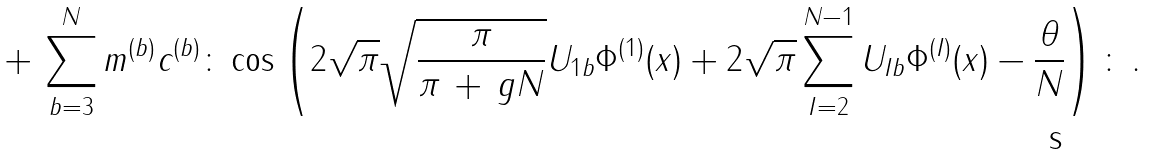Convert formula to latex. <formula><loc_0><loc_0><loc_500><loc_500>+ \, \sum _ { b = 3 } ^ { N } m ^ { ( b ) } c ^ { ( b ) } \colon \cos \left ( 2 \sqrt { \pi } \sqrt { \frac { \pi } { \pi \, + \, g N } } U _ { 1 b } \Phi ^ { ( 1 ) } ( x ) + 2 \sqrt { \pi } \sum _ { I = 2 } ^ { N - 1 } U _ { I b } \Phi ^ { ( I ) } ( x ) - \frac { \theta } { N } \right ) \colon \, .</formula> 